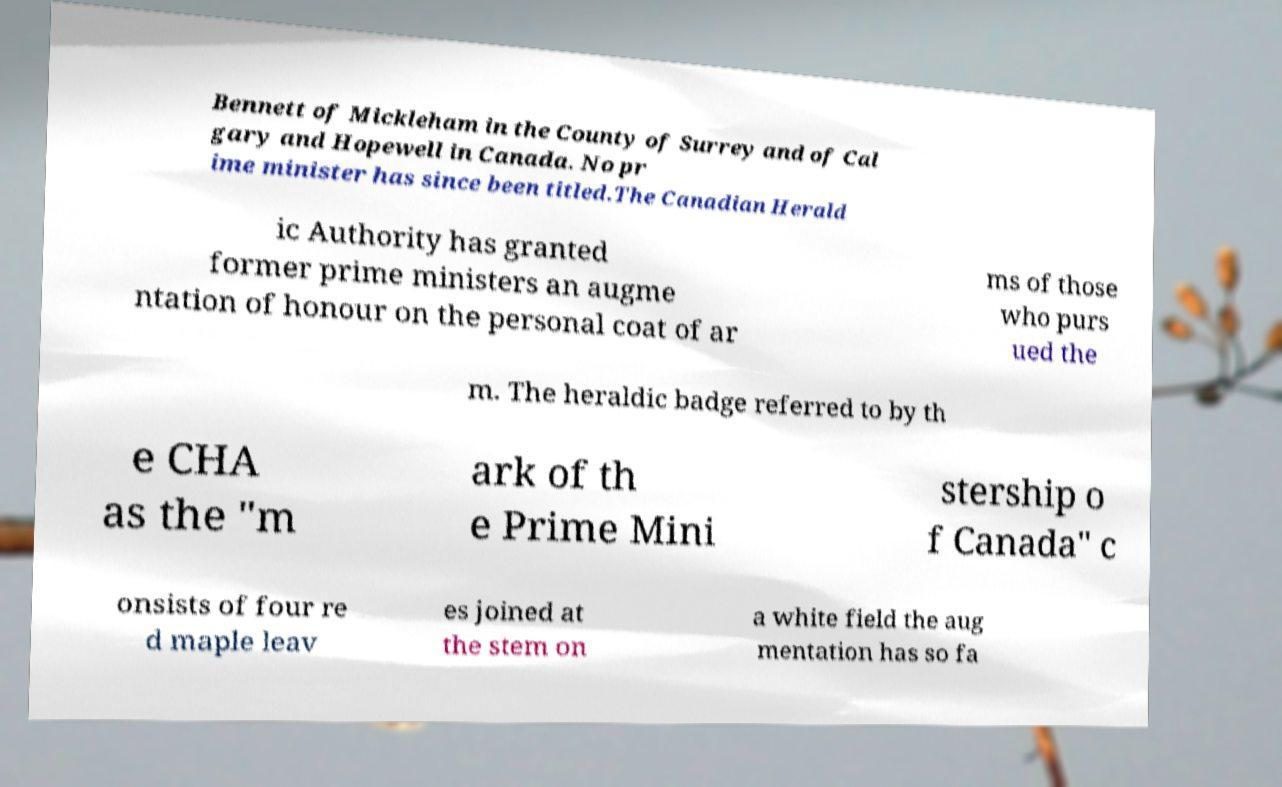Please read and relay the text visible in this image. What does it say? Bennett of Mickleham in the County of Surrey and of Cal gary and Hopewell in Canada. No pr ime minister has since been titled.The Canadian Herald ic Authority has granted former prime ministers an augme ntation of honour on the personal coat of ar ms of those who purs ued the m. The heraldic badge referred to by th e CHA as the "m ark of th e Prime Mini stership o f Canada" c onsists of four re d maple leav es joined at the stem on a white field the aug mentation has so fa 